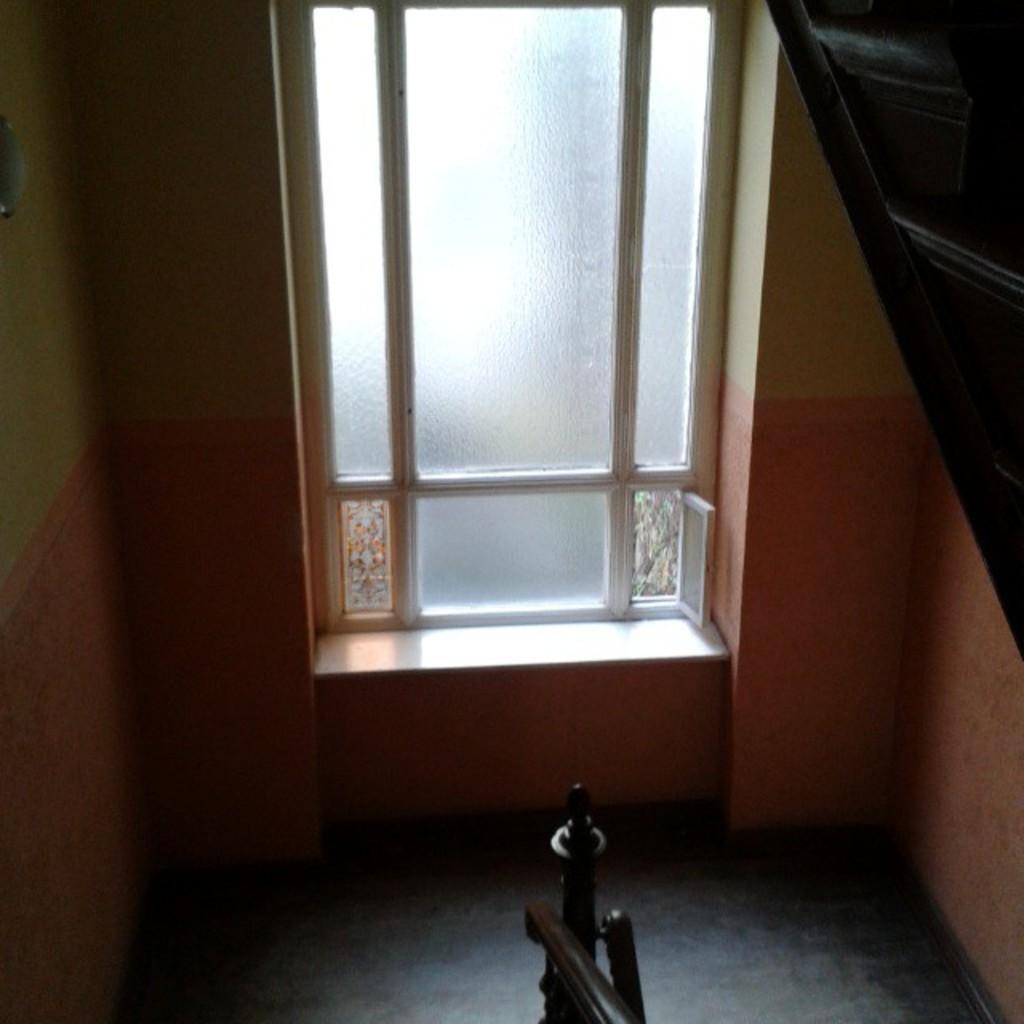In one or two sentences, can you explain what this image depicts? In this image there is a window truncated towards the top of the image, there is the wall truncated towards the top of the image, there is the wall truncated towards the left of the image, there is wall truncated towards the right of the image, there is an object truncated towards the right of the image, there is an object truncated towards the bottom of the image, there is an object truncated towards the bottom of the image. 